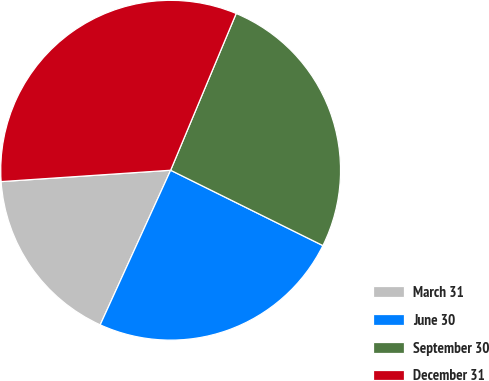<chart> <loc_0><loc_0><loc_500><loc_500><pie_chart><fcel>March 31<fcel>June 30<fcel>September 30<fcel>December 31<nl><fcel>17.13%<fcel>24.49%<fcel>26.01%<fcel>32.37%<nl></chart> 